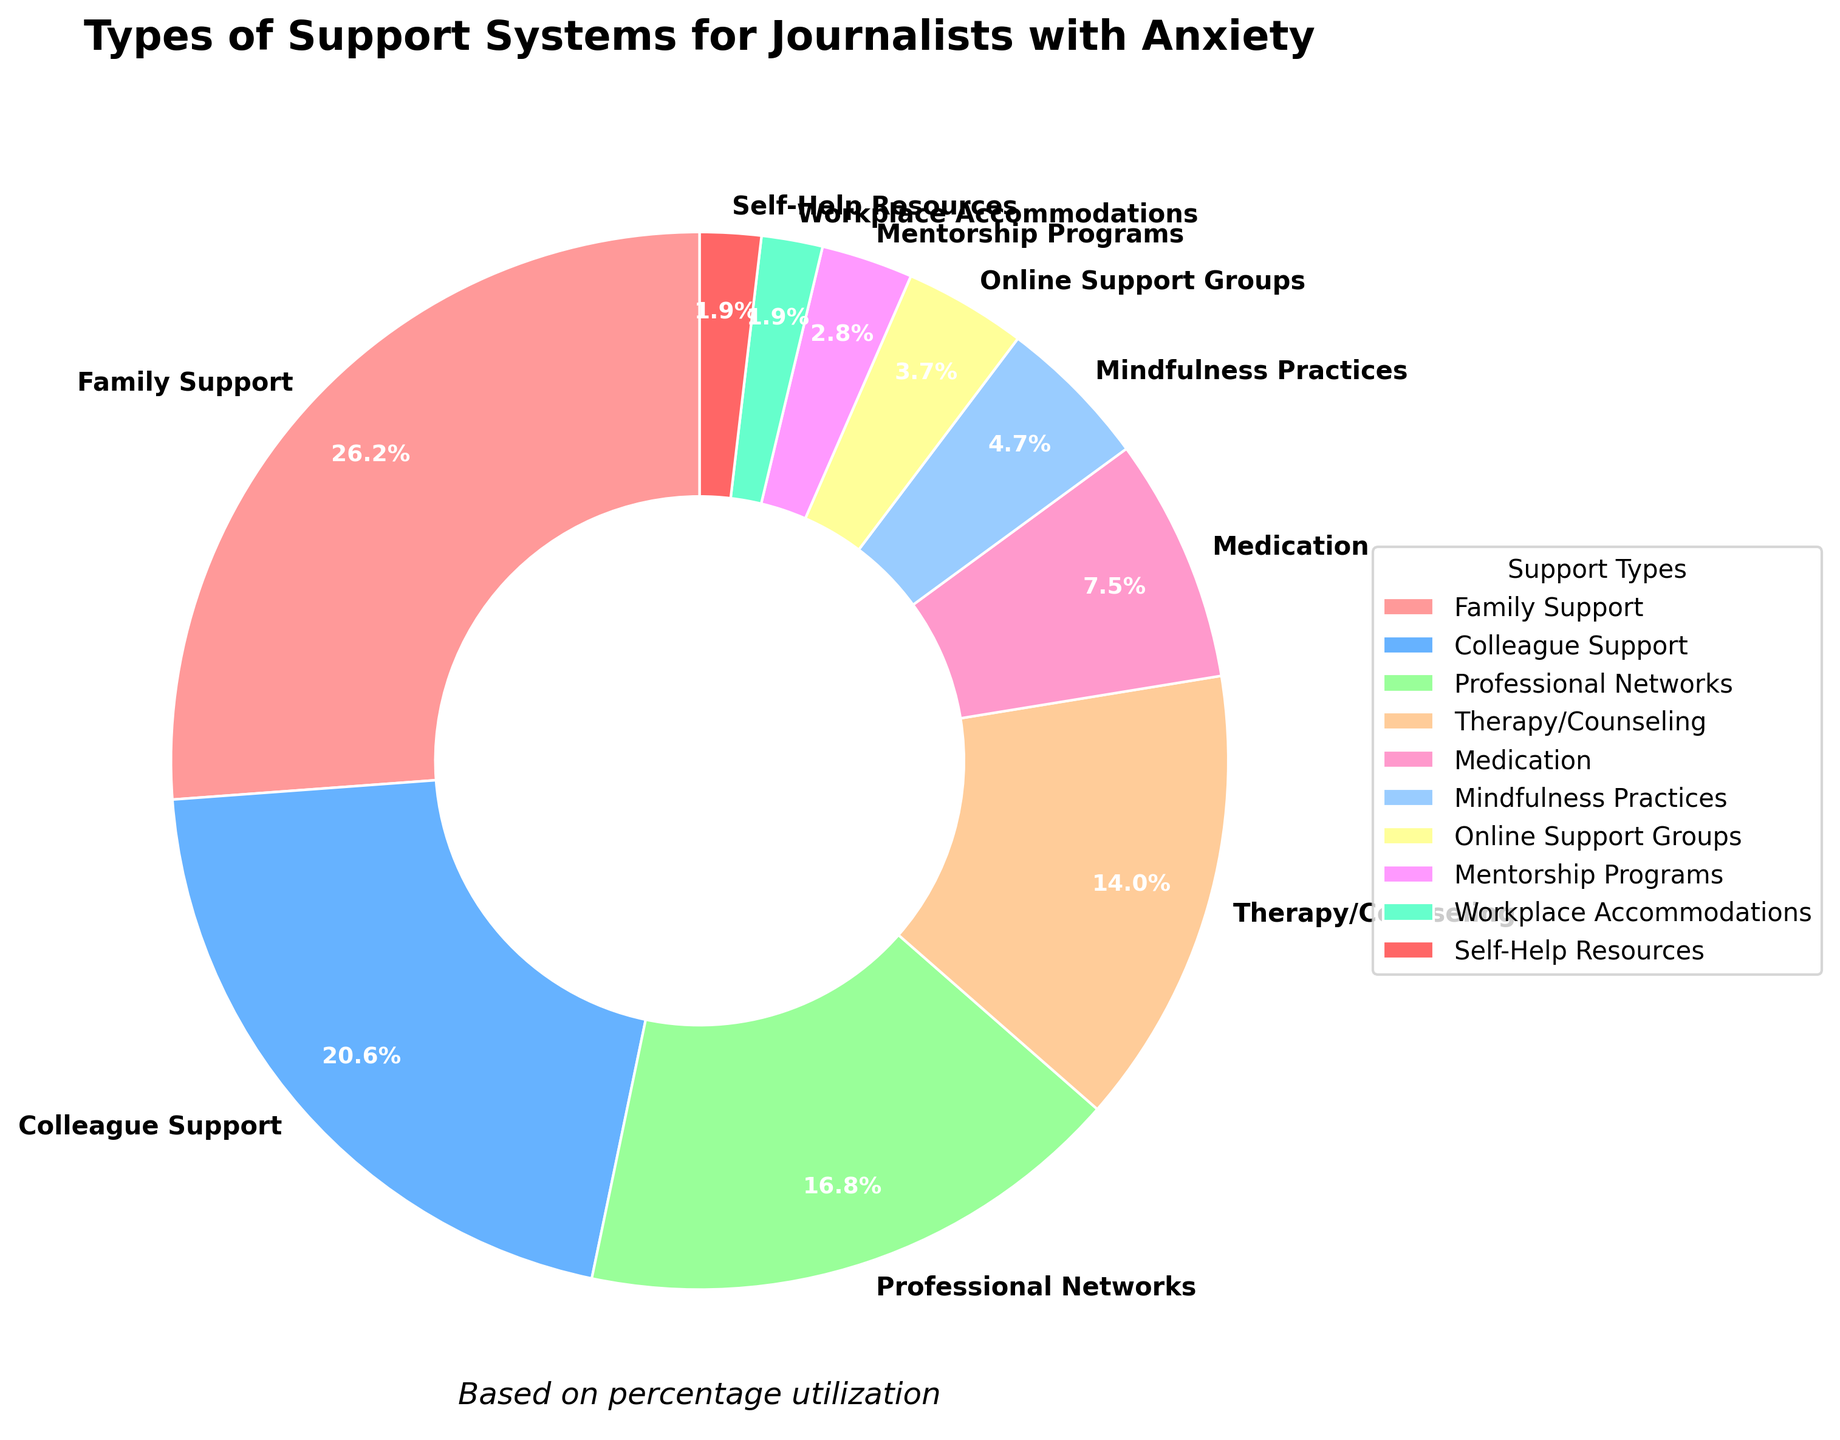What is the most commonly utilized support system by journalists with anxiety? Look at the segment of the pie chart with the largest percentage. The largest segment represents 28%, which corresponds to Family Support.
Answer: Family Support Which support system has the smallest percentage utilization? Identify the smallest segment in the pie chart. The smallest segment represents 2%, which corresponds to both Workplace Accommodations and Self-Help Resources.
Answer: Workplace Accommodations and Self-Help Resources How much more common is Family Support compared to Mindfulness Practices? Family Support is 28%, and Mindfulness Practices are 5%. Subtract 5 from 28 to find the difference. 28 - 5 = 23.
Answer: 23% What is the combined percentage of Colleague Support and Professional Networks? Colleague Support is 22% and Professional Networks is 18%. Add these two percentages together: 22 + 18 = 40.
Answer: 40% Are online support groups more or less utilized than therapy/counseling? Therapy/Counseling is 15%, and Online Support Groups are 4%. Compare these two values. Therapy/Counseling is more utilized.
Answer: More What percentage of journalists use Medication and Mindfulness Practices combined? Medication is 8%, and Mindfulness Practices are 5%. Add these two percentages together: 8 + 5 = 13.
Answer: 13% Which support system category uses a green color? Identify the color associated with a specific support type in the pie chart. The green color corresponds to Professional Networks.
Answer: Professional Networks How many support systems have a percentage utilization of less than 10%? Find the segments of the pie chart with percentages below 10%: Medication (8%), Mindfulness Practices (5%), Online Support Groups (4%), Mentorship Programs (3%), Workplace Accommodations (2%), and Self-Help Resources (2%). Count these segments: 6.
Answer: 6 What are the top three support systems utilized by journalists with anxiety? Identify the three largest segments in the pie chart in descending order of percentage. The top three are Family Support (28%), Colleague Support (22%), and Professional Networks (18%).
Answer: Family Support, Colleague Support, Professional Networks 